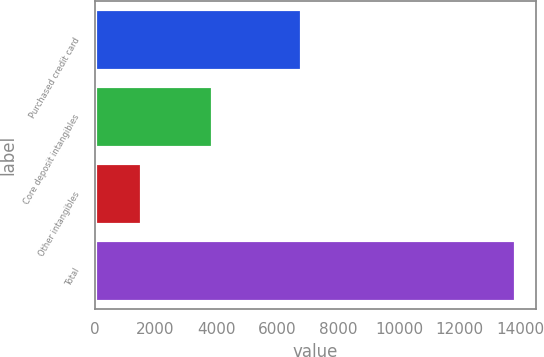Convert chart to OTSL. <chart><loc_0><loc_0><loc_500><loc_500><bar_chart><fcel>Purchased credit card<fcel>Core deposit intangibles<fcel>Other intangibles<fcel>Total<nl><fcel>6790<fcel>3850<fcel>1525<fcel>13815<nl></chart> 